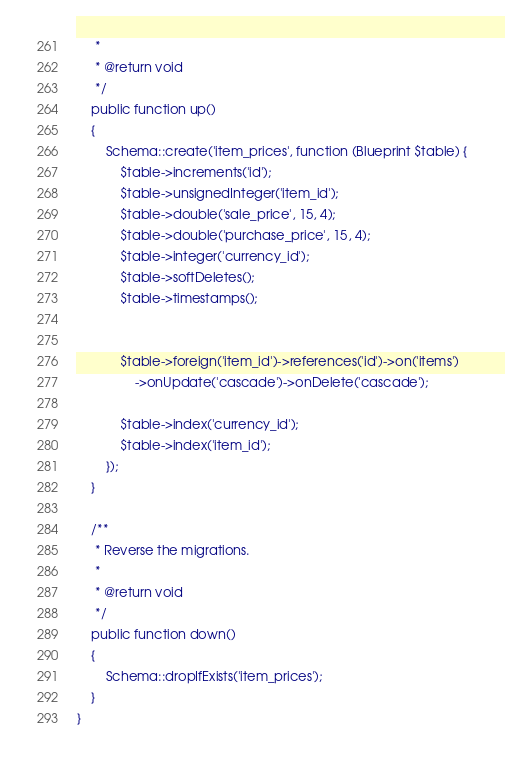<code> <loc_0><loc_0><loc_500><loc_500><_PHP_>     *
     * @return void
     */
    public function up()
    {
        Schema::create('item_prices', function (Blueprint $table) {
            $table->increments('id');
            $table->unsignedInteger('item_id');
            $table->double('sale_price', 15, 4);
            $table->double('purchase_price', 15, 4);
            $table->integer('currency_id');
            $table->softDeletes();
            $table->timestamps();


            $table->foreign('item_id')->references('id')->on('items')
                ->onUpdate('cascade')->onDelete('cascade');

            $table->index('currency_id');
            $table->index('item_id');
        });
    }

    /**
     * Reverse the migrations.
     *
     * @return void
     */
    public function down()
    {
        Schema::dropIfExists('item_prices');
    }
}
</code> 